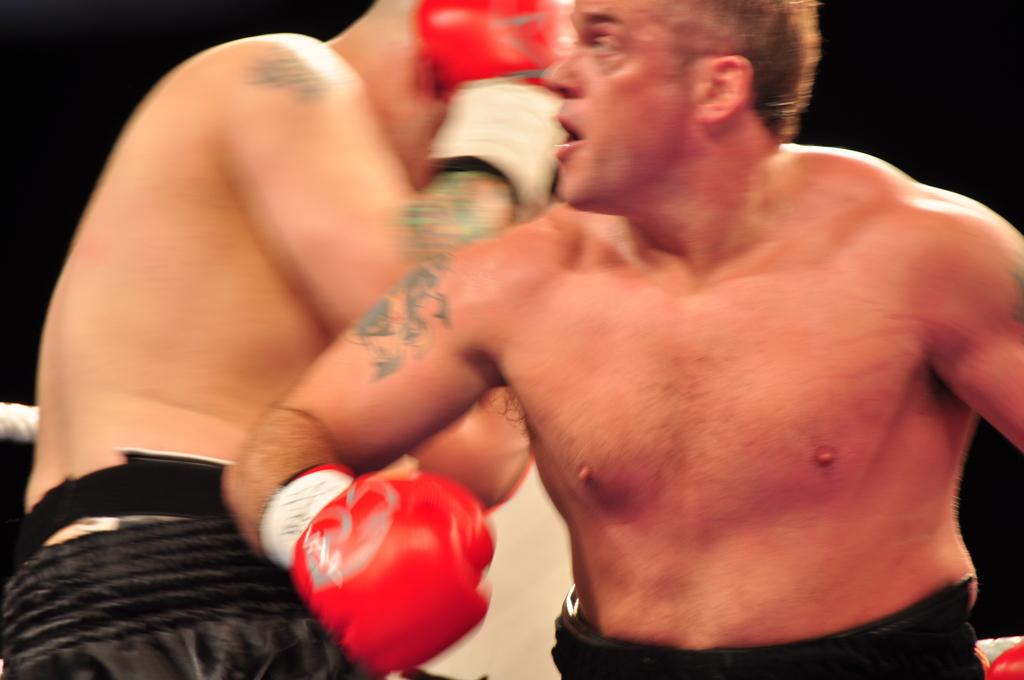How many people are in the image? There are two persons in the image. What are the persons wearing on their hands? The persons are wearing gloves on their hands. What object can be seen in the image besides the persons? There is a rope in the image. What is the color of the background in the image? The background of the image is dark. How many cows can be seen grazing in the background of the image? There are no cows present in the image; the background is dark. What type of cracker is being held by one of the persons in the image? There is no cracker present in the image. 